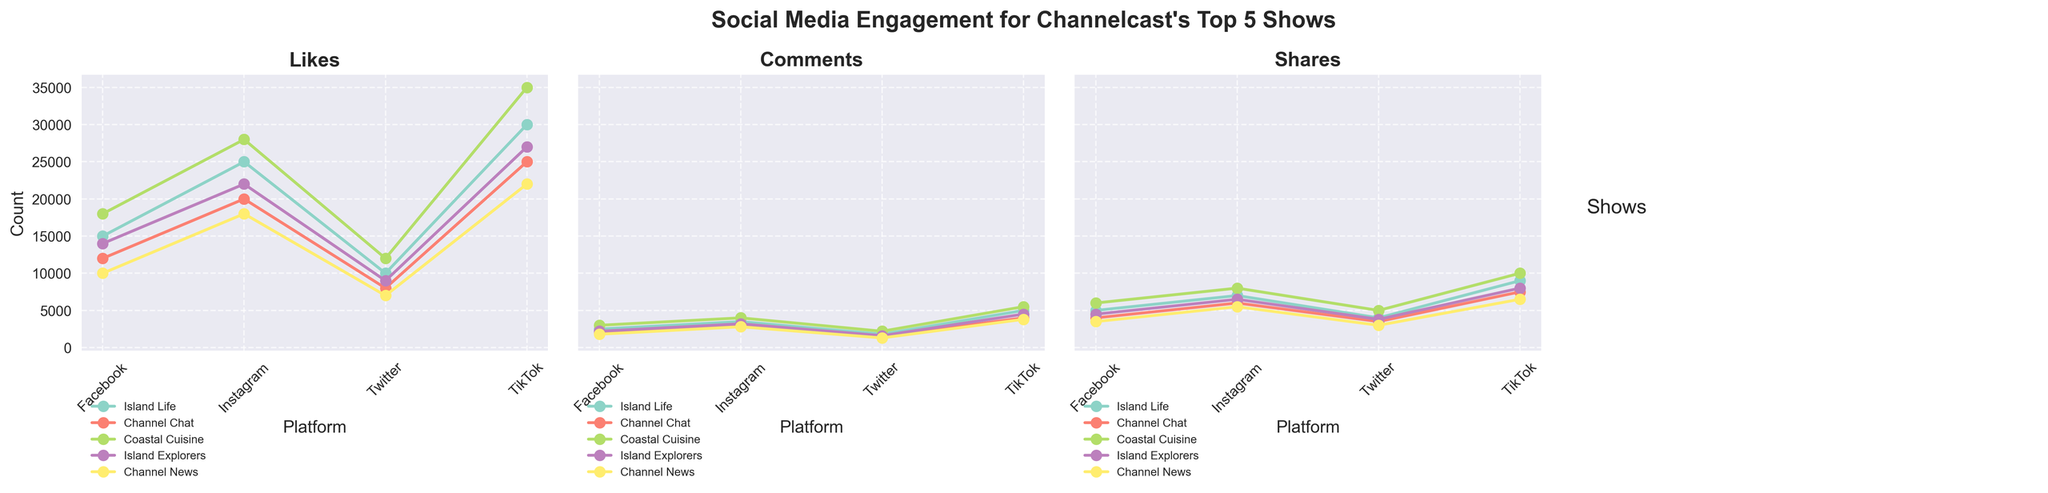Which show has the highest number of likes on TikTok? Look at the plot for "Likes" and find the value at the 'TikTok' point for each show. "Coastal Cuisine" has the highest number of likes on TikTok with 35,000 likes as indicated by the peak in the graph.
Answer: Coastal Cuisine Between Facebook and Twitter, which platform has a higher number of total comments for "Channel Chat"? Sum the comments for "Channel Chat" on Facebook and Twitter. Facebook has 2000 comments, and Twitter has 1500 comments. Facebook has a total of 2000 comments, which is higher than Twitter's 1500 comments.
Answer: Facebook What is the total number of shares for "Island Life" across all platforms? Add the number of shares for "Island Life" across Facebook, Instagram, Twitter, and TikTok. The total is 5000 (Facebook) + 7000 (Instagram) + 4000 (Twitter) + 9000 (TikTok) = 25000 shares.
Answer: 25000 Which platform has the lowest number of likes for "Channel News"? Look at the plot for "Likes" and find the lowest value for "Channel News" among Facebook, Instagram, Twitter, and TikTok. Twitter has the lowest number of likes for "Channel News" with 7000 likes.
Answer: Twitter On which platform does "Island Explorers" have the highest engagement based on the number of comments? Examine the plot for "Comments" to find which platform "Island Explorers" receives the highest comments. TikTok has the highest number of comments for "Island Explorers" with 4500 comments.
Answer: TikTok What is the difference in the number of shares between "Island Life" and "Island Explorers" on TikTok? Find the shares on TikTok for both shows. "Island Life" has 9000 shares and "Island Explorers" has 8000 shares. The difference is 9000 - 8000 = 1000 shares.
Answer: 1000 Which show has the steepest increase in likes from Instagram to TikTok? By visually comparing the slope of the lines between Instagram and TikTok in the "Likes" plot, "Coastal Cuisine" shows the steepest increase, going from 28000 to 35000 likes, a difference of 7000 likes, which is the highest among all shows.
Answer: Coastal Cuisine Comparing the engagement (likes, comments, and shares), does "Island Life" have more engagement on Instagram or Facebook? Add up likes, comments, and shares for "Island Life" on Instagram and Facebook. Instagram: 25000 (likes) + 3500 (comments) + 7000 (shares) = 35500. Facebook: 15000 (likes) + 2500 (comments) + 5000 (shares) = 22500. Instagram has higher total engagement.
Answer: Instagram 